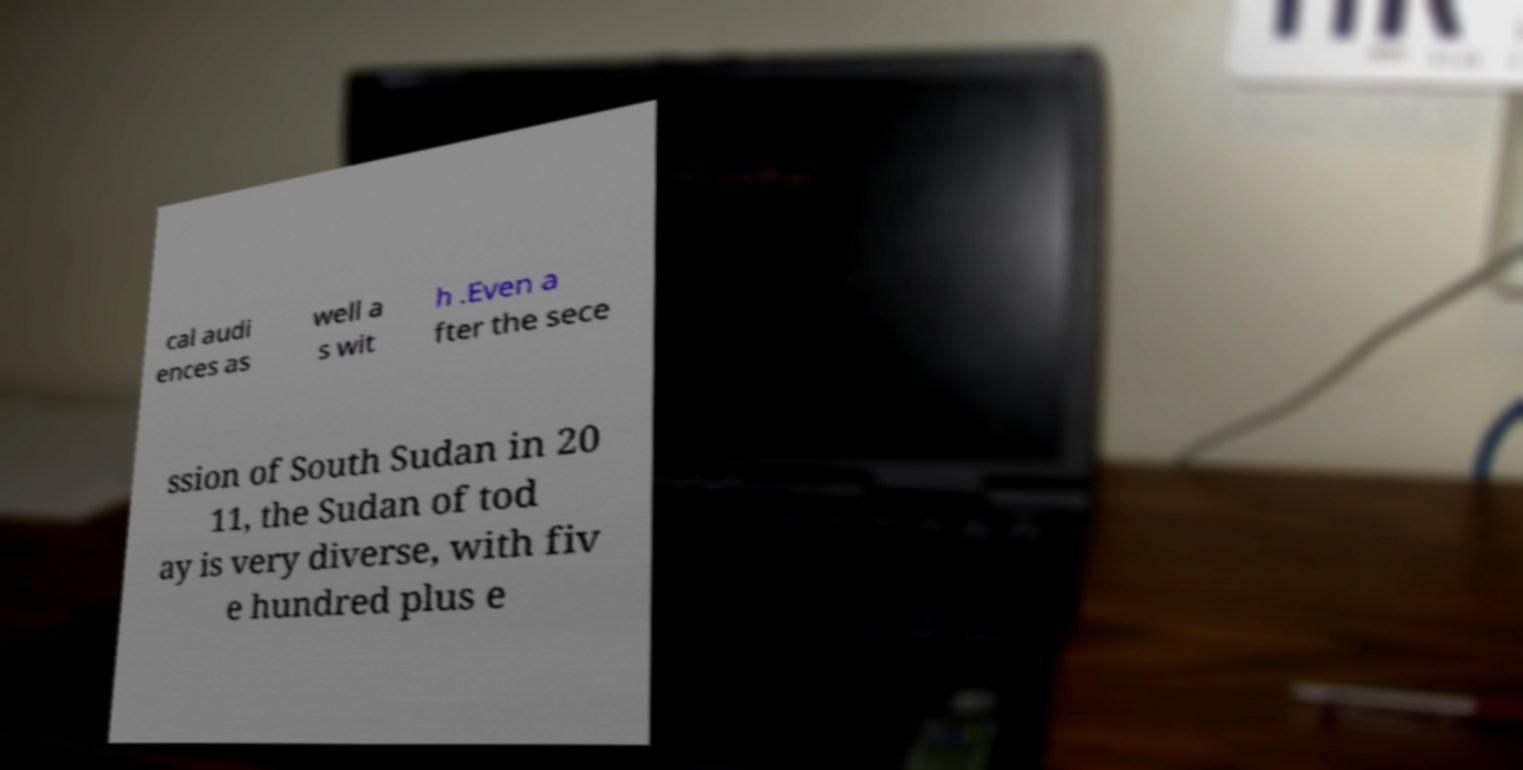Please identify and transcribe the text found in this image. cal audi ences as well a s wit h .Even a fter the sece ssion of South Sudan in 20 11, the Sudan of tod ay is very diverse, with fiv e hundred plus e 